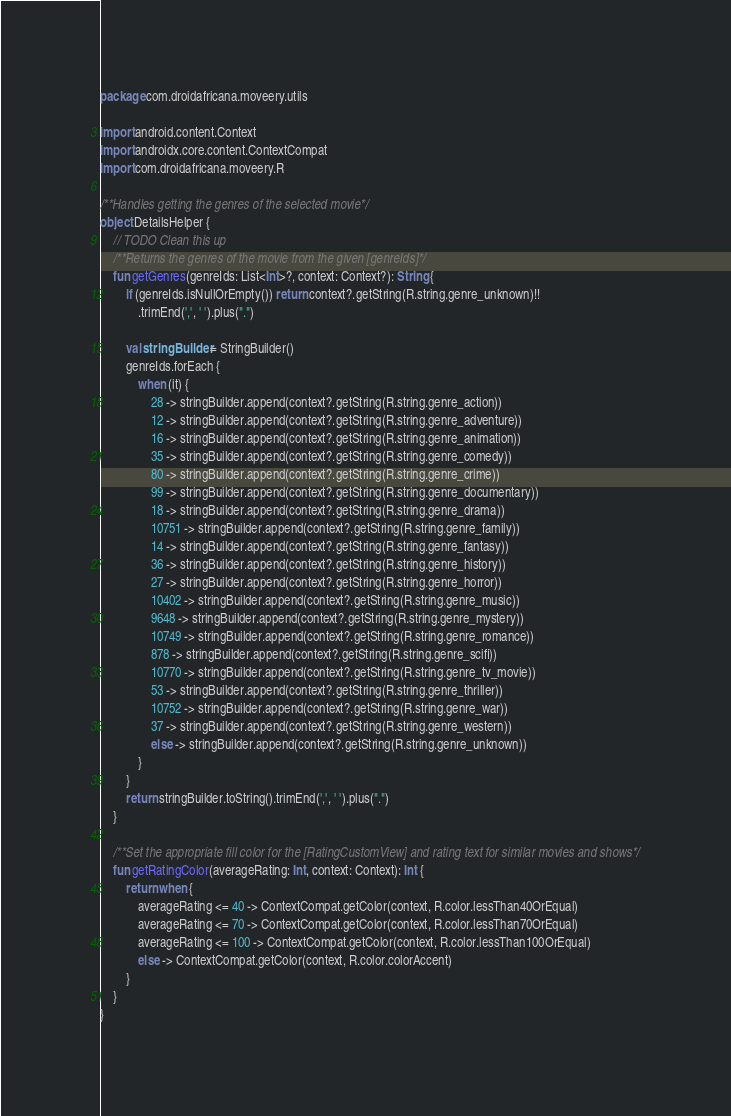Convert code to text. <code><loc_0><loc_0><loc_500><loc_500><_Kotlin_>package com.droidafricana.moveery.utils

import android.content.Context
import androidx.core.content.ContextCompat
import com.droidafricana.moveery.R

/**Handles getting the genres of the selected movie*/
object DetailsHelper {
    // TODO Clean this up
    /**Returns the genres of the movie from the given [genreIds]*/
    fun getGenres(genreIds: List<Int>?, context: Context?): String {
        if (genreIds.isNullOrEmpty()) return context?.getString(R.string.genre_unknown)!!
            .trimEnd(',', ' ').plus(".")

        val stringBuilder = StringBuilder()
        genreIds.forEach {
            when (it) {
                28 -> stringBuilder.append(context?.getString(R.string.genre_action))
                12 -> stringBuilder.append(context?.getString(R.string.genre_adventure))
                16 -> stringBuilder.append(context?.getString(R.string.genre_animation))
                35 -> stringBuilder.append(context?.getString(R.string.genre_comedy))
                80 -> stringBuilder.append(context?.getString(R.string.genre_crime))
                99 -> stringBuilder.append(context?.getString(R.string.genre_documentary))
                18 -> stringBuilder.append(context?.getString(R.string.genre_drama))
                10751 -> stringBuilder.append(context?.getString(R.string.genre_family))
                14 -> stringBuilder.append(context?.getString(R.string.genre_fantasy))
                36 -> stringBuilder.append(context?.getString(R.string.genre_history))
                27 -> stringBuilder.append(context?.getString(R.string.genre_horror))
                10402 -> stringBuilder.append(context?.getString(R.string.genre_music))
                9648 -> stringBuilder.append(context?.getString(R.string.genre_mystery))
                10749 -> stringBuilder.append(context?.getString(R.string.genre_romance))
                878 -> stringBuilder.append(context?.getString(R.string.genre_scifi))
                10770 -> stringBuilder.append(context?.getString(R.string.genre_tv_movie))
                53 -> stringBuilder.append(context?.getString(R.string.genre_thriller))
                10752 -> stringBuilder.append(context?.getString(R.string.genre_war))
                37 -> stringBuilder.append(context?.getString(R.string.genre_western))
                else -> stringBuilder.append(context?.getString(R.string.genre_unknown))
            }
        }
        return stringBuilder.toString().trimEnd(',', ' ').plus(".")
    }

    /**Set the appropriate fill color for the [RatingCustomView] and rating text for similar movies and shows*/
    fun getRatingColor(averageRating: Int, context: Context): Int {
        return when {
            averageRating <= 40 -> ContextCompat.getColor(context, R.color.lessThan40OrEqual)
            averageRating <= 70 -> ContextCompat.getColor(context, R.color.lessThan70OrEqual)
            averageRating <= 100 -> ContextCompat.getColor(context, R.color.lessThan100OrEqual)
            else -> ContextCompat.getColor(context, R.color.colorAccent)
        }
    }
}
</code> 